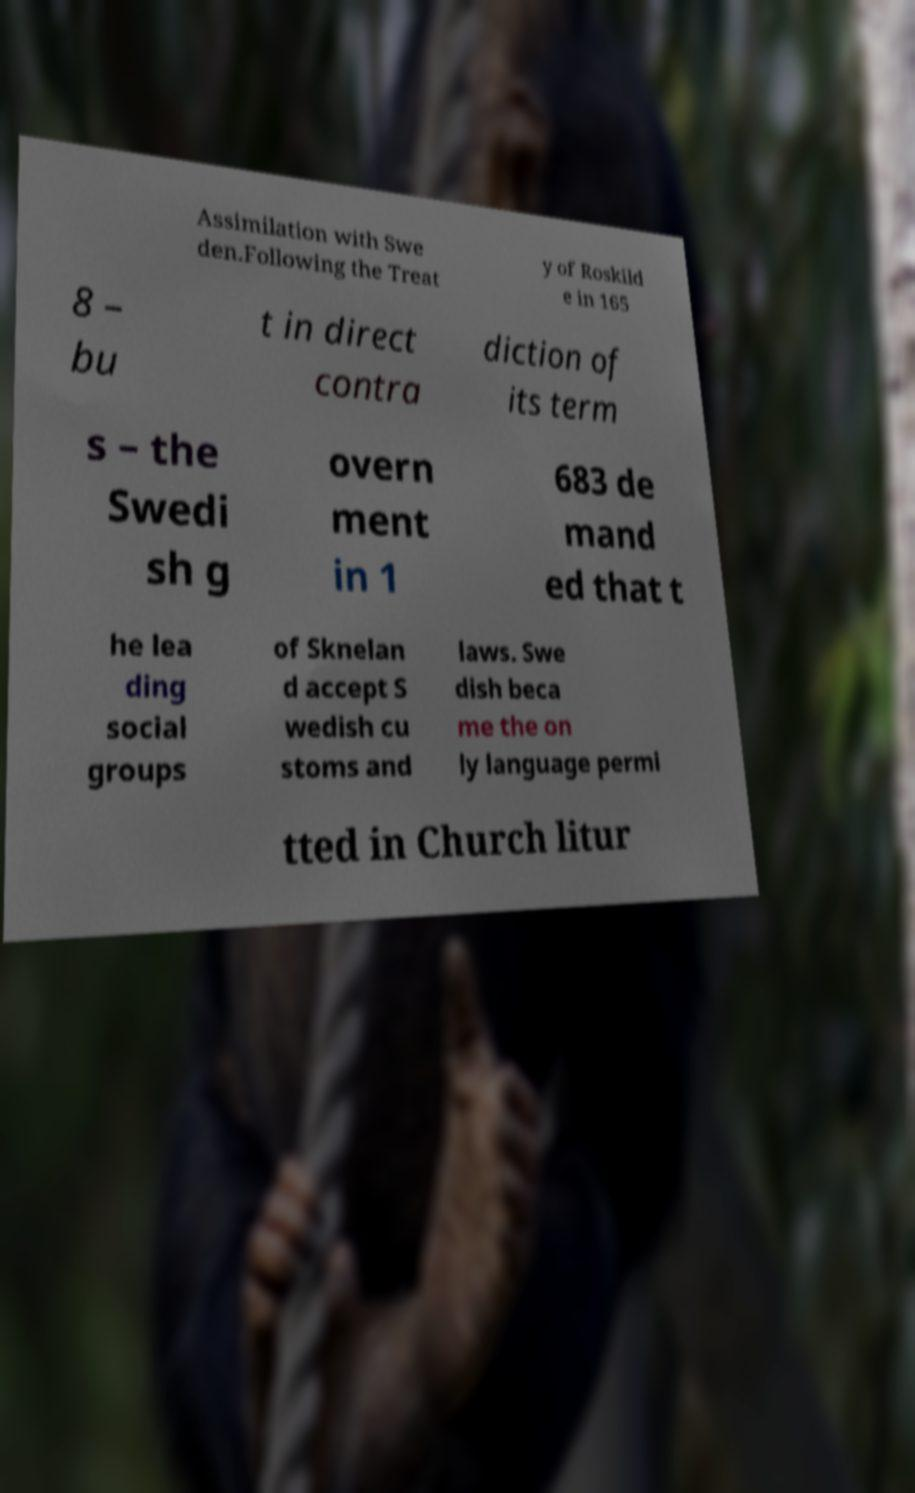I need the written content from this picture converted into text. Can you do that? Assimilation with Swe den.Following the Treat y of Roskild e in 165 8 – bu t in direct contra diction of its term s – the Swedi sh g overn ment in 1 683 de mand ed that t he lea ding social groups of Sknelan d accept S wedish cu stoms and laws. Swe dish beca me the on ly language permi tted in Church litur 